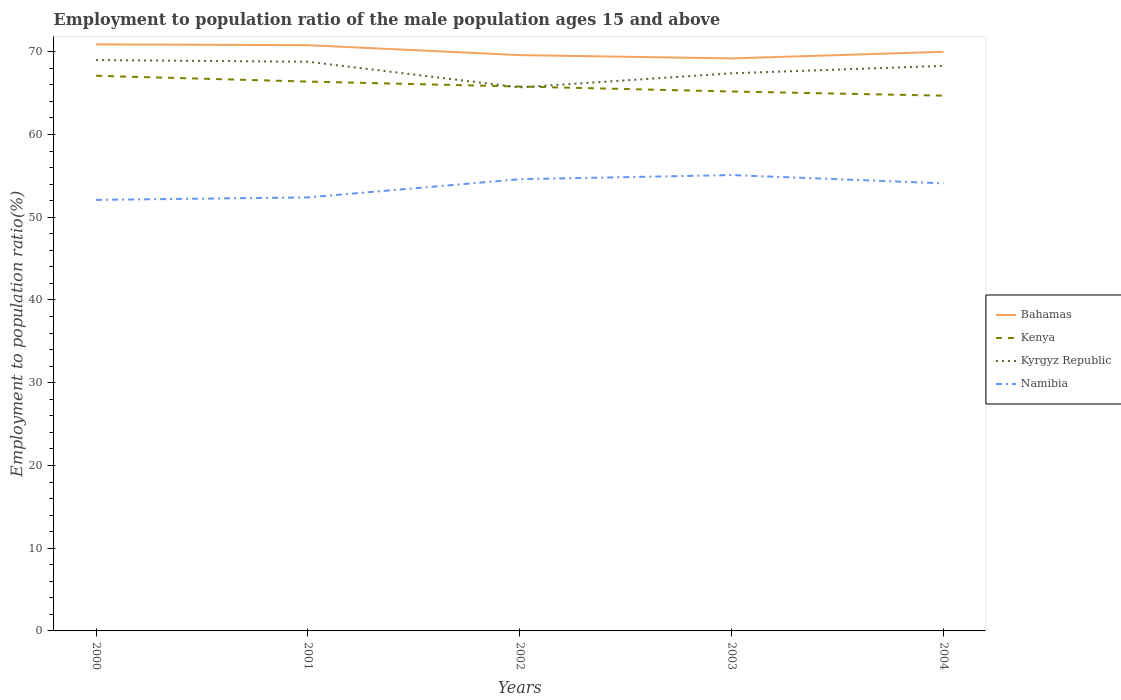How many different coloured lines are there?
Give a very brief answer. 4. Does the line corresponding to Namibia intersect with the line corresponding to Kenya?
Keep it short and to the point. No. Is the number of lines equal to the number of legend labels?
Offer a very short reply. Yes. Across all years, what is the maximum employment to population ratio in Kenya?
Offer a very short reply. 64.7. In which year was the employment to population ratio in Bahamas maximum?
Ensure brevity in your answer.  2003. What is the total employment to population ratio in Kenya in the graph?
Your answer should be very brief. 1.2. Does the graph contain any zero values?
Provide a short and direct response. No. What is the title of the graph?
Your answer should be very brief. Employment to population ratio of the male population ages 15 and above. Does "Tuvalu" appear as one of the legend labels in the graph?
Keep it short and to the point. No. What is the Employment to population ratio(%) of Bahamas in 2000?
Provide a succinct answer. 70.9. What is the Employment to population ratio(%) in Kenya in 2000?
Offer a terse response. 67.1. What is the Employment to population ratio(%) in Namibia in 2000?
Your response must be concise. 52.1. What is the Employment to population ratio(%) in Bahamas in 2001?
Ensure brevity in your answer.  70.8. What is the Employment to population ratio(%) in Kenya in 2001?
Keep it short and to the point. 66.4. What is the Employment to population ratio(%) in Kyrgyz Republic in 2001?
Offer a very short reply. 68.8. What is the Employment to population ratio(%) of Namibia in 2001?
Keep it short and to the point. 52.4. What is the Employment to population ratio(%) of Bahamas in 2002?
Give a very brief answer. 69.6. What is the Employment to population ratio(%) in Kenya in 2002?
Provide a succinct answer. 65.8. What is the Employment to population ratio(%) in Kyrgyz Republic in 2002?
Offer a terse response. 65.7. What is the Employment to population ratio(%) in Namibia in 2002?
Provide a short and direct response. 54.6. What is the Employment to population ratio(%) in Bahamas in 2003?
Make the answer very short. 69.2. What is the Employment to population ratio(%) in Kenya in 2003?
Provide a short and direct response. 65.2. What is the Employment to population ratio(%) in Kyrgyz Republic in 2003?
Provide a succinct answer. 67.4. What is the Employment to population ratio(%) in Namibia in 2003?
Make the answer very short. 55.1. What is the Employment to population ratio(%) in Kenya in 2004?
Your answer should be very brief. 64.7. What is the Employment to population ratio(%) in Kyrgyz Republic in 2004?
Offer a terse response. 68.3. What is the Employment to population ratio(%) in Namibia in 2004?
Your response must be concise. 54.1. Across all years, what is the maximum Employment to population ratio(%) in Bahamas?
Give a very brief answer. 70.9. Across all years, what is the maximum Employment to population ratio(%) of Kenya?
Your response must be concise. 67.1. Across all years, what is the maximum Employment to population ratio(%) in Kyrgyz Republic?
Ensure brevity in your answer.  69. Across all years, what is the maximum Employment to population ratio(%) of Namibia?
Give a very brief answer. 55.1. Across all years, what is the minimum Employment to population ratio(%) of Bahamas?
Give a very brief answer. 69.2. Across all years, what is the minimum Employment to population ratio(%) of Kenya?
Give a very brief answer. 64.7. Across all years, what is the minimum Employment to population ratio(%) of Kyrgyz Republic?
Ensure brevity in your answer.  65.7. Across all years, what is the minimum Employment to population ratio(%) of Namibia?
Provide a short and direct response. 52.1. What is the total Employment to population ratio(%) of Bahamas in the graph?
Make the answer very short. 350.5. What is the total Employment to population ratio(%) of Kenya in the graph?
Ensure brevity in your answer.  329.2. What is the total Employment to population ratio(%) in Kyrgyz Republic in the graph?
Keep it short and to the point. 339.2. What is the total Employment to population ratio(%) of Namibia in the graph?
Provide a succinct answer. 268.3. What is the difference between the Employment to population ratio(%) in Namibia in 2000 and that in 2001?
Your answer should be compact. -0.3. What is the difference between the Employment to population ratio(%) in Kenya in 2000 and that in 2002?
Provide a short and direct response. 1.3. What is the difference between the Employment to population ratio(%) of Kyrgyz Republic in 2000 and that in 2002?
Provide a succinct answer. 3.3. What is the difference between the Employment to population ratio(%) of Kenya in 2000 and that in 2003?
Provide a short and direct response. 1.9. What is the difference between the Employment to population ratio(%) in Kyrgyz Republic in 2000 and that in 2004?
Give a very brief answer. 0.7. What is the difference between the Employment to population ratio(%) of Namibia in 2000 and that in 2004?
Your response must be concise. -2. What is the difference between the Employment to population ratio(%) of Bahamas in 2001 and that in 2002?
Provide a short and direct response. 1.2. What is the difference between the Employment to population ratio(%) of Kenya in 2001 and that in 2002?
Your answer should be compact. 0.6. What is the difference between the Employment to population ratio(%) in Kyrgyz Republic in 2001 and that in 2003?
Offer a very short reply. 1.4. What is the difference between the Employment to population ratio(%) of Namibia in 2001 and that in 2003?
Make the answer very short. -2.7. What is the difference between the Employment to population ratio(%) in Bahamas in 2002 and that in 2003?
Your answer should be compact. 0.4. What is the difference between the Employment to population ratio(%) of Kenya in 2002 and that in 2003?
Give a very brief answer. 0.6. What is the difference between the Employment to population ratio(%) of Kyrgyz Republic in 2002 and that in 2003?
Keep it short and to the point. -1.7. What is the difference between the Employment to population ratio(%) in Bahamas in 2003 and that in 2004?
Your response must be concise. -0.8. What is the difference between the Employment to population ratio(%) in Kenya in 2003 and that in 2004?
Ensure brevity in your answer.  0.5. What is the difference between the Employment to population ratio(%) of Kyrgyz Republic in 2003 and that in 2004?
Offer a very short reply. -0.9. What is the difference between the Employment to population ratio(%) of Namibia in 2003 and that in 2004?
Offer a very short reply. 1. What is the difference between the Employment to population ratio(%) of Bahamas in 2000 and the Employment to population ratio(%) of Namibia in 2001?
Give a very brief answer. 18.5. What is the difference between the Employment to population ratio(%) of Kenya in 2000 and the Employment to population ratio(%) of Namibia in 2001?
Your response must be concise. 14.7. What is the difference between the Employment to population ratio(%) in Kyrgyz Republic in 2000 and the Employment to population ratio(%) in Namibia in 2001?
Offer a very short reply. 16.6. What is the difference between the Employment to population ratio(%) in Bahamas in 2000 and the Employment to population ratio(%) in Kenya in 2002?
Keep it short and to the point. 5.1. What is the difference between the Employment to population ratio(%) of Kenya in 2000 and the Employment to population ratio(%) of Namibia in 2002?
Give a very brief answer. 12.5. What is the difference between the Employment to population ratio(%) of Bahamas in 2000 and the Employment to population ratio(%) of Kenya in 2003?
Make the answer very short. 5.7. What is the difference between the Employment to population ratio(%) in Bahamas in 2000 and the Employment to population ratio(%) in Namibia in 2003?
Your answer should be compact. 15.8. What is the difference between the Employment to population ratio(%) of Kenya in 2000 and the Employment to population ratio(%) of Kyrgyz Republic in 2003?
Keep it short and to the point. -0.3. What is the difference between the Employment to population ratio(%) in Bahamas in 2000 and the Employment to population ratio(%) in Kyrgyz Republic in 2004?
Provide a succinct answer. 2.6. What is the difference between the Employment to population ratio(%) of Kenya in 2000 and the Employment to population ratio(%) of Namibia in 2004?
Offer a terse response. 13. What is the difference between the Employment to population ratio(%) of Kyrgyz Republic in 2000 and the Employment to population ratio(%) of Namibia in 2004?
Make the answer very short. 14.9. What is the difference between the Employment to population ratio(%) of Bahamas in 2001 and the Employment to population ratio(%) of Kenya in 2002?
Provide a succinct answer. 5. What is the difference between the Employment to population ratio(%) in Bahamas in 2001 and the Employment to population ratio(%) in Kyrgyz Republic in 2002?
Your answer should be very brief. 5.1. What is the difference between the Employment to population ratio(%) in Bahamas in 2001 and the Employment to population ratio(%) in Namibia in 2002?
Offer a terse response. 16.2. What is the difference between the Employment to population ratio(%) of Kyrgyz Republic in 2001 and the Employment to population ratio(%) of Namibia in 2002?
Provide a succinct answer. 14.2. What is the difference between the Employment to population ratio(%) of Kenya in 2001 and the Employment to population ratio(%) of Kyrgyz Republic in 2003?
Your answer should be very brief. -1. What is the difference between the Employment to population ratio(%) in Kenya in 2001 and the Employment to population ratio(%) in Namibia in 2003?
Ensure brevity in your answer.  11.3. What is the difference between the Employment to population ratio(%) in Kyrgyz Republic in 2001 and the Employment to population ratio(%) in Namibia in 2003?
Ensure brevity in your answer.  13.7. What is the difference between the Employment to population ratio(%) of Bahamas in 2001 and the Employment to population ratio(%) of Kenya in 2004?
Give a very brief answer. 6.1. What is the difference between the Employment to population ratio(%) of Bahamas in 2001 and the Employment to population ratio(%) of Namibia in 2004?
Provide a succinct answer. 16.7. What is the difference between the Employment to population ratio(%) of Kenya in 2001 and the Employment to population ratio(%) of Kyrgyz Republic in 2004?
Ensure brevity in your answer.  -1.9. What is the difference between the Employment to population ratio(%) in Bahamas in 2002 and the Employment to population ratio(%) in Kyrgyz Republic in 2003?
Provide a succinct answer. 2.2. What is the difference between the Employment to population ratio(%) in Kenya in 2002 and the Employment to population ratio(%) in Kyrgyz Republic in 2003?
Make the answer very short. -1.6. What is the difference between the Employment to population ratio(%) in Bahamas in 2002 and the Employment to population ratio(%) in Kenya in 2004?
Make the answer very short. 4.9. What is the difference between the Employment to population ratio(%) in Kyrgyz Republic in 2002 and the Employment to population ratio(%) in Namibia in 2004?
Ensure brevity in your answer.  11.6. What is the difference between the Employment to population ratio(%) in Bahamas in 2003 and the Employment to population ratio(%) in Kenya in 2004?
Offer a very short reply. 4.5. What is the difference between the Employment to population ratio(%) of Bahamas in 2003 and the Employment to population ratio(%) of Kyrgyz Republic in 2004?
Give a very brief answer. 0.9. What is the average Employment to population ratio(%) of Bahamas per year?
Your answer should be compact. 70.1. What is the average Employment to population ratio(%) in Kenya per year?
Offer a terse response. 65.84. What is the average Employment to population ratio(%) of Kyrgyz Republic per year?
Ensure brevity in your answer.  67.84. What is the average Employment to population ratio(%) of Namibia per year?
Provide a short and direct response. 53.66. In the year 2000, what is the difference between the Employment to population ratio(%) of Bahamas and Employment to population ratio(%) of Kyrgyz Republic?
Your answer should be very brief. 1.9. In the year 2000, what is the difference between the Employment to population ratio(%) of Bahamas and Employment to population ratio(%) of Namibia?
Your response must be concise. 18.8. In the year 2000, what is the difference between the Employment to population ratio(%) of Kyrgyz Republic and Employment to population ratio(%) of Namibia?
Your response must be concise. 16.9. In the year 2001, what is the difference between the Employment to population ratio(%) in Bahamas and Employment to population ratio(%) in Kyrgyz Republic?
Provide a short and direct response. 2. In the year 2001, what is the difference between the Employment to population ratio(%) of Kenya and Employment to population ratio(%) of Kyrgyz Republic?
Ensure brevity in your answer.  -2.4. In the year 2001, what is the difference between the Employment to population ratio(%) in Kenya and Employment to population ratio(%) in Namibia?
Provide a short and direct response. 14. In the year 2002, what is the difference between the Employment to population ratio(%) in Bahamas and Employment to population ratio(%) in Kyrgyz Republic?
Provide a succinct answer. 3.9. In the year 2002, what is the difference between the Employment to population ratio(%) of Bahamas and Employment to population ratio(%) of Namibia?
Make the answer very short. 15. In the year 2002, what is the difference between the Employment to population ratio(%) in Kenya and Employment to population ratio(%) in Kyrgyz Republic?
Offer a very short reply. 0.1. In the year 2002, what is the difference between the Employment to population ratio(%) in Kenya and Employment to population ratio(%) in Namibia?
Your response must be concise. 11.2. In the year 2002, what is the difference between the Employment to population ratio(%) of Kyrgyz Republic and Employment to population ratio(%) of Namibia?
Provide a succinct answer. 11.1. In the year 2003, what is the difference between the Employment to population ratio(%) of Bahamas and Employment to population ratio(%) of Kyrgyz Republic?
Your answer should be very brief. 1.8. In the year 2003, what is the difference between the Employment to population ratio(%) in Kenya and Employment to population ratio(%) in Namibia?
Make the answer very short. 10.1. In the year 2003, what is the difference between the Employment to population ratio(%) in Kyrgyz Republic and Employment to population ratio(%) in Namibia?
Provide a short and direct response. 12.3. In the year 2004, what is the difference between the Employment to population ratio(%) of Bahamas and Employment to population ratio(%) of Kenya?
Your response must be concise. 5.3. In the year 2004, what is the difference between the Employment to population ratio(%) of Bahamas and Employment to population ratio(%) of Namibia?
Offer a very short reply. 15.9. In the year 2004, what is the difference between the Employment to population ratio(%) in Kyrgyz Republic and Employment to population ratio(%) in Namibia?
Give a very brief answer. 14.2. What is the ratio of the Employment to population ratio(%) of Kenya in 2000 to that in 2001?
Provide a short and direct response. 1.01. What is the ratio of the Employment to population ratio(%) of Kyrgyz Republic in 2000 to that in 2001?
Provide a succinct answer. 1. What is the ratio of the Employment to population ratio(%) in Namibia in 2000 to that in 2001?
Your answer should be compact. 0.99. What is the ratio of the Employment to population ratio(%) of Bahamas in 2000 to that in 2002?
Ensure brevity in your answer.  1.02. What is the ratio of the Employment to population ratio(%) of Kenya in 2000 to that in 2002?
Keep it short and to the point. 1.02. What is the ratio of the Employment to population ratio(%) in Kyrgyz Republic in 2000 to that in 2002?
Provide a short and direct response. 1.05. What is the ratio of the Employment to population ratio(%) of Namibia in 2000 to that in 2002?
Keep it short and to the point. 0.95. What is the ratio of the Employment to population ratio(%) in Bahamas in 2000 to that in 2003?
Ensure brevity in your answer.  1.02. What is the ratio of the Employment to population ratio(%) of Kenya in 2000 to that in 2003?
Offer a very short reply. 1.03. What is the ratio of the Employment to population ratio(%) in Kyrgyz Republic in 2000 to that in 2003?
Your answer should be very brief. 1.02. What is the ratio of the Employment to population ratio(%) in Namibia in 2000 to that in 2003?
Provide a short and direct response. 0.95. What is the ratio of the Employment to population ratio(%) in Bahamas in 2000 to that in 2004?
Give a very brief answer. 1.01. What is the ratio of the Employment to population ratio(%) of Kenya in 2000 to that in 2004?
Keep it short and to the point. 1.04. What is the ratio of the Employment to population ratio(%) in Kyrgyz Republic in 2000 to that in 2004?
Offer a very short reply. 1.01. What is the ratio of the Employment to population ratio(%) of Bahamas in 2001 to that in 2002?
Give a very brief answer. 1.02. What is the ratio of the Employment to population ratio(%) in Kenya in 2001 to that in 2002?
Provide a succinct answer. 1.01. What is the ratio of the Employment to population ratio(%) in Kyrgyz Republic in 2001 to that in 2002?
Provide a succinct answer. 1.05. What is the ratio of the Employment to population ratio(%) in Namibia in 2001 to that in 2002?
Provide a succinct answer. 0.96. What is the ratio of the Employment to population ratio(%) of Bahamas in 2001 to that in 2003?
Provide a short and direct response. 1.02. What is the ratio of the Employment to population ratio(%) in Kenya in 2001 to that in 2003?
Give a very brief answer. 1.02. What is the ratio of the Employment to population ratio(%) of Kyrgyz Republic in 2001 to that in 2003?
Give a very brief answer. 1.02. What is the ratio of the Employment to population ratio(%) in Namibia in 2001 to that in 2003?
Offer a terse response. 0.95. What is the ratio of the Employment to population ratio(%) in Bahamas in 2001 to that in 2004?
Make the answer very short. 1.01. What is the ratio of the Employment to population ratio(%) of Kenya in 2001 to that in 2004?
Your answer should be compact. 1.03. What is the ratio of the Employment to population ratio(%) in Kyrgyz Republic in 2001 to that in 2004?
Ensure brevity in your answer.  1.01. What is the ratio of the Employment to population ratio(%) of Namibia in 2001 to that in 2004?
Provide a succinct answer. 0.97. What is the ratio of the Employment to population ratio(%) in Kenya in 2002 to that in 2003?
Give a very brief answer. 1.01. What is the ratio of the Employment to population ratio(%) of Kyrgyz Republic in 2002 to that in 2003?
Your response must be concise. 0.97. What is the ratio of the Employment to population ratio(%) of Namibia in 2002 to that in 2003?
Ensure brevity in your answer.  0.99. What is the ratio of the Employment to population ratio(%) of Bahamas in 2002 to that in 2004?
Keep it short and to the point. 0.99. What is the ratio of the Employment to population ratio(%) of Kyrgyz Republic in 2002 to that in 2004?
Provide a succinct answer. 0.96. What is the ratio of the Employment to population ratio(%) of Namibia in 2002 to that in 2004?
Offer a terse response. 1.01. What is the ratio of the Employment to population ratio(%) of Bahamas in 2003 to that in 2004?
Offer a very short reply. 0.99. What is the ratio of the Employment to population ratio(%) of Kenya in 2003 to that in 2004?
Offer a terse response. 1.01. What is the ratio of the Employment to population ratio(%) in Namibia in 2003 to that in 2004?
Keep it short and to the point. 1.02. What is the difference between the highest and the second highest Employment to population ratio(%) in Kenya?
Offer a very short reply. 0.7. What is the difference between the highest and the second highest Employment to population ratio(%) in Kyrgyz Republic?
Offer a terse response. 0.2. What is the difference between the highest and the lowest Employment to population ratio(%) in Bahamas?
Provide a short and direct response. 1.7. 